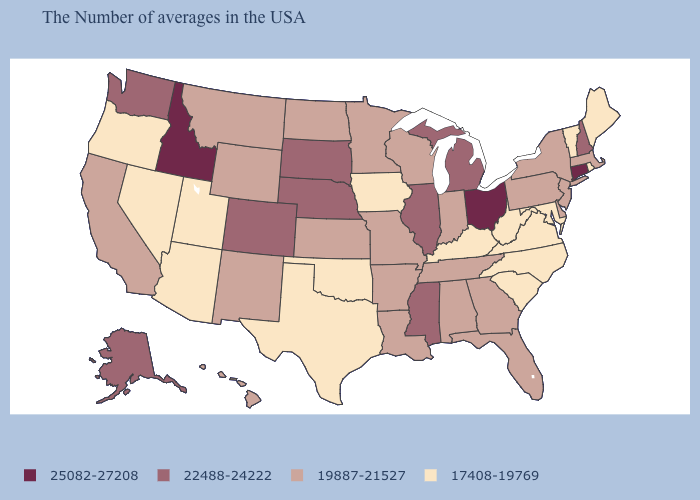Is the legend a continuous bar?
Keep it brief. No. Does Iowa have the lowest value in the USA?
Answer briefly. Yes. What is the value of Idaho?
Quick response, please. 25082-27208. Among the states that border Massachusetts , which have the highest value?
Concise answer only. Connecticut. Name the states that have a value in the range 22488-24222?
Answer briefly. New Hampshire, Michigan, Illinois, Mississippi, Nebraska, South Dakota, Colorado, Washington, Alaska. Name the states that have a value in the range 25082-27208?
Quick response, please. Connecticut, Ohio, Idaho. Name the states that have a value in the range 19887-21527?
Concise answer only. Massachusetts, New York, New Jersey, Delaware, Pennsylvania, Florida, Georgia, Indiana, Alabama, Tennessee, Wisconsin, Louisiana, Missouri, Arkansas, Minnesota, Kansas, North Dakota, Wyoming, New Mexico, Montana, California, Hawaii. What is the lowest value in the USA?
Quick response, please. 17408-19769. Does the map have missing data?
Be succinct. No. Which states have the lowest value in the West?
Quick response, please. Utah, Arizona, Nevada, Oregon. Does Mississippi have the lowest value in the South?
Concise answer only. No. Does Georgia have the same value as Arizona?
Concise answer only. No. What is the value of Georgia?
Quick response, please. 19887-21527. Does Texas have the lowest value in the USA?
Give a very brief answer. Yes. Which states hav the highest value in the West?
Give a very brief answer. Idaho. 